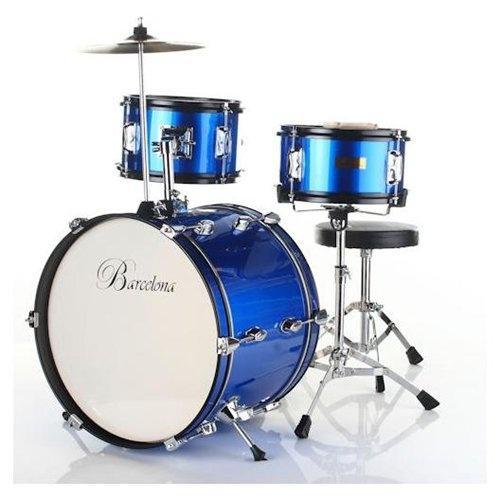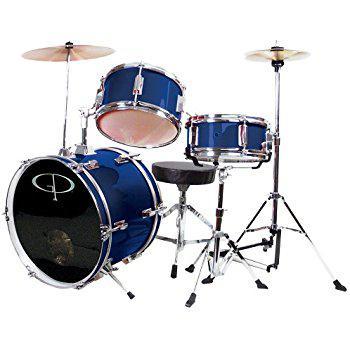The first image is the image on the left, the second image is the image on the right. Analyze the images presented: Is the assertion "The drumkit on the right has a large drum positioned on its side with a black face showing, and the drumkit on the left has a large drum with a white face." valid? Answer yes or no. Yes. The first image is the image on the left, the second image is the image on the right. Given the left and right images, does the statement "One of the kick drums has a black front." hold true? Answer yes or no. Yes. 